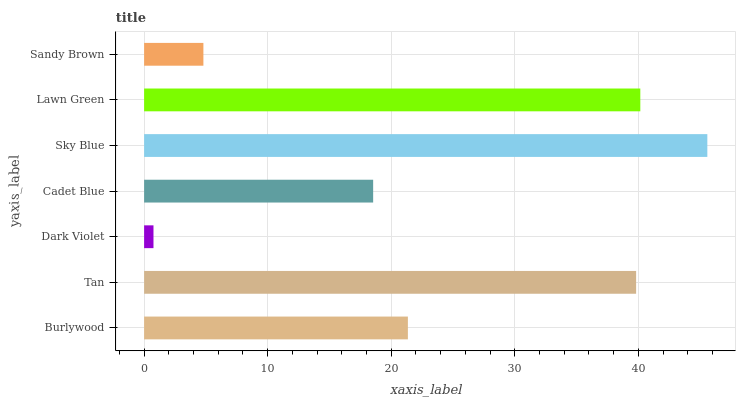Is Dark Violet the minimum?
Answer yes or no. Yes. Is Sky Blue the maximum?
Answer yes or no. Yes. Is Tan the minimum?
Answer yes or no. No. Is Tan the maximum?
Answer yes or no. No. Is Tan greater than Burlywood?
Answer yes or no. Yes. Is Burlywood less than Tan?
Answer yes or no. Yes. Is Burlywood greater than Tan?
Answer yes or no. No. Is Tan less than Burlywood?
Answer yes or no. No. Is Burlywood the high median?
Answer yes or no. Yes. Is Burlywood the low median?
Answer yes or no. Yes. Is Lawn Green the high median?
Answer yes or no. No. Is Tan the low median?
Answer yes or no. No. 